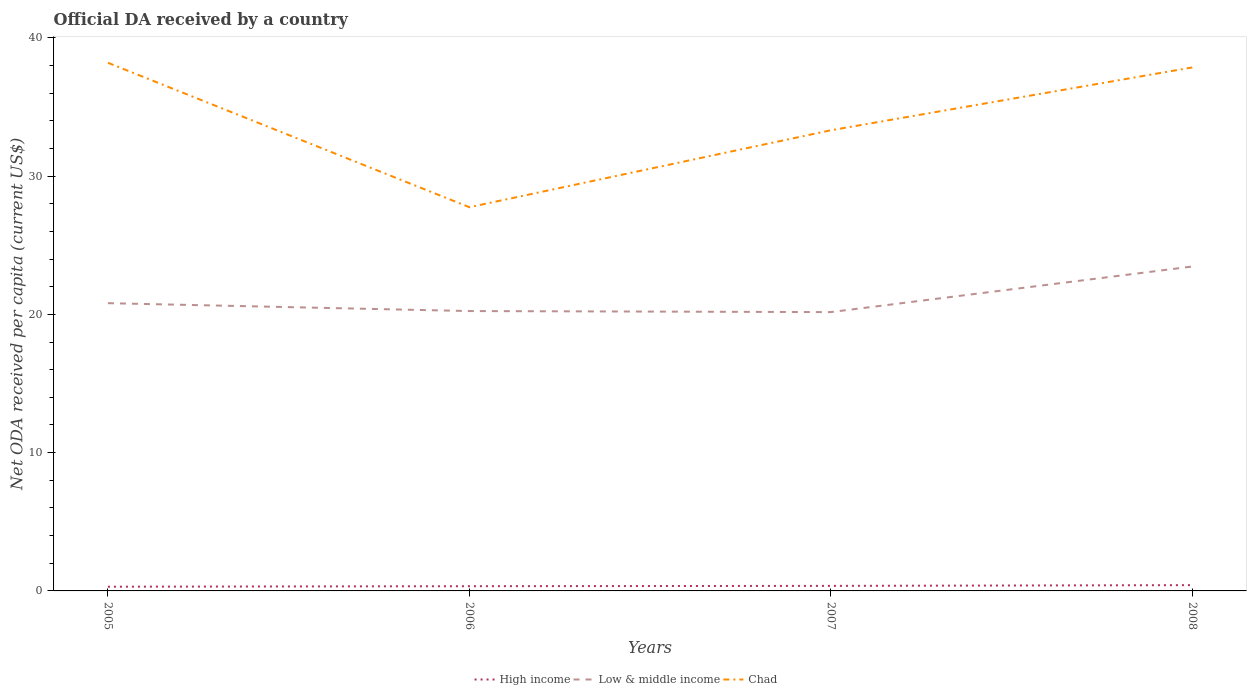How many different coloured lines are there?
Provide a succinct answer. 3. Is the number of lines equal to the number of legend labels?
Your answer should be compact. Yes. Across all years, what is the maximum ODA received in in Low & middle income?
Your response must be concise. 20.16. What is the total ODA received in in Chad in the graph?
Keep it short and to the point. -4.54. What is the difference between the highest and the second highest ODA received in in High income?
Provide a short and direct response. 0.11. How many years are there in the graph?
Offer a very short reply. 4. Does the graph contain any zero values?
Give a very brief answer. No. Does the graph contain grids?
Keep it short and to the point. No. Where does the legend appear in the graph?
Make the answer very short. Bottom center. What is the title of the graph?
Your answer should be very brief. Official DA received by a country. What is the label or title of the Y-axis?
Ensure brevity in your answer.  Net ODA received per capita (current US$). What is the Net ODA received per capita (current US$) in High income in 2005?
Keep it short and to the point. 0.3. What is the Net ODA received per capita (current US$) of Low & middle income in 2005?
Offer a terse response. 20.81. What is the Net ODA received per capita (current US$) in Chad in 2005?
Your response must be concise. 38.19. What is the Net ODA received per capita (current US$) in High income in 2006?
Make the answer very short. 0.34. What is the Net ODA received per capita (current US$) of Low & middle income in 2006?
Offer a terse response. 20.24. What is the Net ODA received per capita (current US$) in Chad in 2006?
Provide a succinct answer. 27.75. What is the Net ODA received per capita (current US$) of High income in 2007?
Provide a succinct answer. 0.36. What is the Net ODA received per capita (current US$) in Low & middle income in 2007?
Provide a succinct answer. 20.16. What is the Net ODA received per capita (current US$) of Chad in 2007?
Keep it short and to the point. 33.31. What is the Net ODA received per capita (current US$) in High income in 2008?
Your response must be concise. 0.42. What is the Net ODA received per capita (current US$) of Low & middle income in 2008?
Offer a terse response. 23.46. What is the Net ODA received per capita (current US$) in Chad in 2008?
Offer a terse response. 37.86. Across all years, what is the maximum Net ODA received per capita (current US$) of High income?
Provide a short and direct response. 0.42. Across all years, what is the maximum Net ODA received per capita (current US$) of Low & middle income?
Offer a very short reply. 23.46. Across all years, what is the maximum Net ODA received per capita (current US$) in Chad?
Offer a terse response. 38.19. Across all years, what is the minimum Net ODA received per capita (current US$) in High income?
Give a very brief answer. 0.3. Across all years, what is the minimum Net ODA received per capita (current US$) of Low & middle income?
Your answer should be compact. 20.16. Across all years, what is the minimum Net ODA received per capita (current US$) of Chad?
Provide a short and direct response. 27.75. What is the total Net ODA received per capita (current US$) in High income in the graph?
Your answer should be very brief. 1.43. What is the total Net ODA received per capita (current US$) of Low & middle income in the graph?
Your answer should be compact. 84.67. What is the total Net ODA received per capita (current US$) in Chad in the graph?
Provide a succinct answer. 137.11. What is the difference between the Net ODA received per capita (current US$) of High income in 2005 and that in 2006?
Provide a short and direct response. -0.04. What is the difference between the Net ODA received per capita (current US$) in Low & middle income in 2005 and that in 2006?
Provide a succinct answer. 0.57. What is the difference between the Net ODA received per capita (current US$) of Chad in 2005 and that in 2006?
Offer a terse response. 10.45. What is the difference between the Net ODA received per capita (current US$) of High income in 2005 and that in 2007?
Provide a short and direct response. -0.06. What is the difference between the Net ODA received per capita (current US$) of Low & middle income in 2005 and that in 2007?
Your response must be concise. 0.65. What is the difference between the Net ODA received per capita (current US$) in Chad in 2005 and that in 2007?
Make the answer very short. 4.88. What is the difference between the Net ODA received per capita (current US$) in High income in 2005 and that in 2008?
Keep it short and to the point. -0.11. What is the difference between the Net ODA received per capita (current US$) of Low & middle income in 2005 and that in 2008?
Offer a terse response. -2.65. What is the difference between the Net ODA received per capita (current US$) in Chad in 2005 and that in 2008?
Ensure brevity in your answer.  0.34. What is the difference between the Net ODA received per capita (current US$) of High income in 2006 and that in 2007?
Provide a succinct answer. -0.02. What is the difference between the Net ODA received per capita (current US$) in Low & middle income in 2006 and that in 2007?
Provide a short and direct response. 0.08. What is the difference between the Net ODA received per capita (current US$) in Chad in 2006 and that in 2007?
Your response must be concise. -5.56. What is the difference between the Net ODA received per capita (current US$) of High income in 2006 and that in 2008?
Make the answer very short. -0.08. What is the difference between the Net ODA received per capita (current US$) in Low & middle income in 2006 and that in 2008?
Provide a short and direct response. -3.22. What is the difference between the Net ODA received per capita (current US$) of Chad in 2006 and that in 2008?
Your response must be concise. -10.11. What is the difference between the Net ODA received per capita (current US$) of High income in 2007 and that in 2008?
Ensure brevity in your answer.  -0.05. What is the difference between the Net ODA received per capita (current US$) of Low & middle income in 2007 and that in 2008?
Your answer should be compact. -3.3. What is the difference between the Net ODA received per capita (current US$) of Chad in 2007 and that in 2008?
Your answer should be compact. -4.54. What is the difference between the Net ODA received per capita (current US$) of High income in 2005 and the Net ODA received per capita (current US$) of Low & middle income in 2006?
Make the answer very short. -19.93. What is the difference between the Net ODA received per capita (current US$) of High income in 2005 and the Net ODA received per capita (current US$) of Chad in 2006?
Your answer should be compact. -27.44. What is the difference between the Net ODA received per capita (current US$) in Low & middle income in 2005 and the Net ODA received per capita (current US$) in Chad in 2006?
Ensure brevity in your answer.  -6.94. What is the difference between the Net ODA received per capita (current US$) of High income in 2005 and the Net ODA received per capita (current US$) of Low & middle income in 2007?
Your response must be concise. -19.86. What is the difference between the Net ODA received per capita (current US$) of High income in 2005 and the Net ODA received per capita (current US$) of Chad in 2007?
Make the answer very short. -33.01. What is the difference between the Net ODA received per capita (current US$) of Low & middle income in 2005 and the Net ODA received per capita (current US$) of Chad in 2007?
Your response must be concise. -12.5. What is the difference between the Net ODA received per capita (current US$) of High income in 2005 and the Net ODA received per capita (current US$) of Low & middle income in 2008?
Make the answer very short. -23.16. What is the difference between the Net ODA received per capita (current US$) of High income in 2005 and the Net ODA received per capita (current US$) of Chad in 2008?
Make the answer very short. -37.55. What is the difference between the Net ODA received per capita (current US$) of Low & middle income in 2005 and the Net ODA received per capita (current US$) of Chad in 2008?
Keep it short and to the point. -17.05. What is the difference between the Net ODA received per capita (current US$) of High income in 2006 and the Net ODA received per capita (current US$) of Low & middle income in 2007?
Ensure brevity in your answer.  -19.82. What is the difference between the Net ODA received per capita (current US$) of High income in 2006 and the Net ODA received per capita (current US$) of Chad in 2007?
Your answer should be very brief. -32.97. What is the difference between the Net ODA received per capita (current US$) in Low & middle income in 2006 and the Net ODA received per capita (current US$) in Chad in 2007?
Provide a short and direct response. -13.07. What is the difference between the Net ODA received per capita (current US$) in High income in 2006 and the Net ODA received per capita (current US$) in Low & middle income in 2008?
Your response must be concise. -23.12. What is the difference between the Net ODA received per capita (current US$) in High income in 2006 and the Net ODA received per capita (current US$) in Chad in 2008?
Make the answer very short. -37.52. What is the difference between the Net ODA received per capita (current US$) of Low & middle income in 2006 and the Net ODA received per capita (current US$) of Chad in 2008?
Your response must be concise. -17.62. What is the difference between the Net ODA received per capita (current US$) of High income in 2007 and the Net ODA received per capita (current US$) of Low & middle income in 2008?
Keep it short and to the point. -23.1. What is the difference between the Net ODA received per capita (current US$) in High income in 2007 and the Net ODA received per capita (current US$) in Chad in 2008?
Offer a very short reply. -37.49. What is the difference between the Net ODA received per capita (current US$) in Low & middle income in 2007 and the Net ODA received per capita (current US$) in Chad in 2008?
Offer a terse response. -17.69. What is the average Net ODA received per capita (current US$) of High income per year?
Provide a short and direct response. 0.36. What is the average Net ODA received per capita (current US$) in Low & middle income per year?
Make the answer very short. 21.17. What is the average Net ODA received per capita (current US$) in Chad per year?
Keep it short and to the point. 34.28. In the year 2005, what is the difference between the Net ODA received per capita (current US$) in High income and Net ODA received per capita (current US$) in Low & middle income?
Provide a short and direct response. -20.5. In the year 2005, what is the difference between the Net ODA received per capita (current US$) of High income and Net ODA received per capita (current US$) of Chad?
Your answer should be very brief. -37.89. In the year 2005, what is the difference between the Net ODA received per capita (current US$) of Low & middle income and Net ODA received per capita (current US$) of Chad?
Your answer should be compact. -17.39. In the year 2006, what is the difference between the Net ODA received per capita (current US$) in High income and Net ODA received per capita (current US$) in Low & middle income?
Your answer should be compact. -19.9. In the year 2006, what is the difference between the Net ODA received per capita (current US$) in High income and Net ODA received per capita (current US$) in Chad?
Provide a short and direct response. -27.41. In the year 2006, what is the difference between the Net ODA received per capita (current US$) of Low & middle income and Net ODA received per capita (current US$) of Chad?
Give a very brief answer. -7.51. In the year 2007, what is the difference between the Net ODA received per capita (current US$) in High income and Net ODA received per capita (current US$) in Low & middle income?
Your response must be concise. -19.8. In the year 2007, what is the difference between the Net ODA received per capita (current US$) in High income and Net ODA received per capita (current US$) in Chad?
Your answer should be compact. -32.95. In the year 2007, what is the difference between the Net ODA received per capita (current US$) in Low & middle income and Net ODA received per capita (current US$) in Chad?
Offer a very short reply. -13.15. In the year 2008, what is the difference between the Net ODA received per capita (current US$) in High income and Net ODA received per capita (current US$) in Low & middle income?
Keep it short and to the point. -23.04. In the year 2008, what is the difference between the Net ODA received per capita (current US$) of High income and Net ODA received per capita (current US$) of Chad?
Offer a very short reply. -37.44. In the year 2008, what is the difference between the Net ODA received per capita (current US$) of Low & middle income and Net ODA received per capita (current US$) of Chad?
Make the answer very short. -14.4. What is the ratio of the Net ODA received per capita (current US$) in High income in 2005 to that in 2006?
Keep it short and to the point. 0.89. What is the ratio of the Net ODA received per capita (current US$) of Low & middle income in 2005 to that in 2006?
Provide a short and direct response. 1.03. What is the ratio of the Net ODA received per capita (current US$) in Chad in 2005 to that in 2006?
Your response must be concise. 1.38. What is the ratio of the Net ODA received per capita (current US$) of High income in 2005 to that in 2007?
Offer a very short reply. 0.84. What is the ratio of the Net ODA received per capita (current US$) in Low & middle income in 2005 to that in 2007?
Provide a succinct answer. 1.03. What is the ratio of the Net ODA received per capita (current US$) of Chad in 2005 to that in 2007?
Your answer should be compact. 1.15. What is the ratio of the Net ODA received per capita (current US$) of High income in 2005 to that in 2008?
Your answer should be very brief. 0.73. What is the ratio of the Net ODA received per capita (current US$) in Low & middle income in 2005 to that in 2008?
Your answer should be very brief. 0.89. What is the ratio of the Net ODA received per capita (current US$) in Chad in 2005 to that in 2008?
Give a very brief answer. 1.01. What is the ratio of the Net ODA received per capita (current US$) in High income in 2006 to that in 2007?
Offer a terse response. 0.94. What is the ratio of the Net ODA received per capita (current US$) of Low & middle income in 2006 to that in 2007?
Make the answer very short. 1. What is the ratio of the Net ODA received per capita (current US$) of Chad in 2006 to that in 2007?
Offer a very short reply. 0.83. What is the ratio of the Net ODA received per capita (current US$) in High income in 2006 to that in 2008?
Offer a terse response. 0.82. What is the ratio of the Net ODA received per capita (current US$) of Low & middle income in 2006 to that in 2008?
Provide a succinct answer. 0.86. What is the ratio of the Net ODA received per capita (current US$) in Chad in 2006 to that in 2008?
Provide a short and direct response. 0.73. What is the ratio of the Net ODA received per capita (current US$) of High income in 2007 to that in 2008?
Your response must be concise. 0.87. What is the ratio of the Net ODA received per capita (current US$) in Low & middle income in 2007 to that in 2008?
Give a very brief answer. 0.86. What is the difference between the highest and the second highest Net ODA received per capita (current US$) of High income?
Your response must be concise. 0.05. What is the difference between the highest and the second highest Net ODA received per capita (current US$) in Low & middle income?
Provide a short and direct response. 2.65. What is the difference between the highest and the second highest Net ODA received per capita (current US$) in Chad?
Your answer should be very brief. 0.34. What is the difference between the highest and the lowest Net ODA received per capita (current US$) in High income?
Ensure brevity in your answer.  0.11. What is the difference between the highest and the lowest Net ODA received per capita (current US$) of Low & middle income?
Ensure brevity in your answer.  3.3. What is the difference between the highest and the lowest Net ODA received per capita (current US$) of Chad?
Provide a short and direct response. 10.45. 